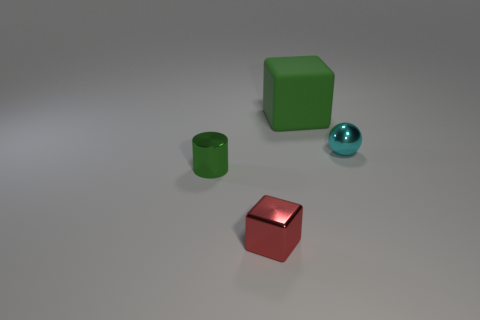Is there anything else that has the same material as the big green cube?
Give a very brief answer. No. Are there any other things that are the same size as the green rubber object?
Make the answer very short. No. Do the large rubber thing and the tiny shiny cylinder have the same color?
Provide a short and direct response. Yes. Are there any other things that are the same shape as the cyan object?
Ensure brevity in your answer.  No. Is there a ball that is to the left of the green thing that is behind the small metallic object behind the green cylinder?
Offer a terse response. No. There is a large rubber object; is it the same color as the tiny thing right of the tiny red thing?
Give a very brief answer. No. How many other blocks have the same color as the shiny block?
Your response must be concise. 0. There is a shiny thing on the right side of the thing behind the small cyan object; what size is it?
Offer a terse response. Small. What number of things are things that are behind the tiny green shiny object or tiny red metal things?
Offer a very short reply. 3. Are there any brown rubber cubes that have the same size as the green shiny object?
Provide a succinct answer. No. 